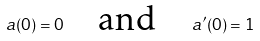Convert formula to latex. <formula><loc_0><loc_0><loc_500><loc_500>a ( 0 ) = 0 \quad \text {and} \quad a ^ { \prime } ( 0 ) = 1</formula> 